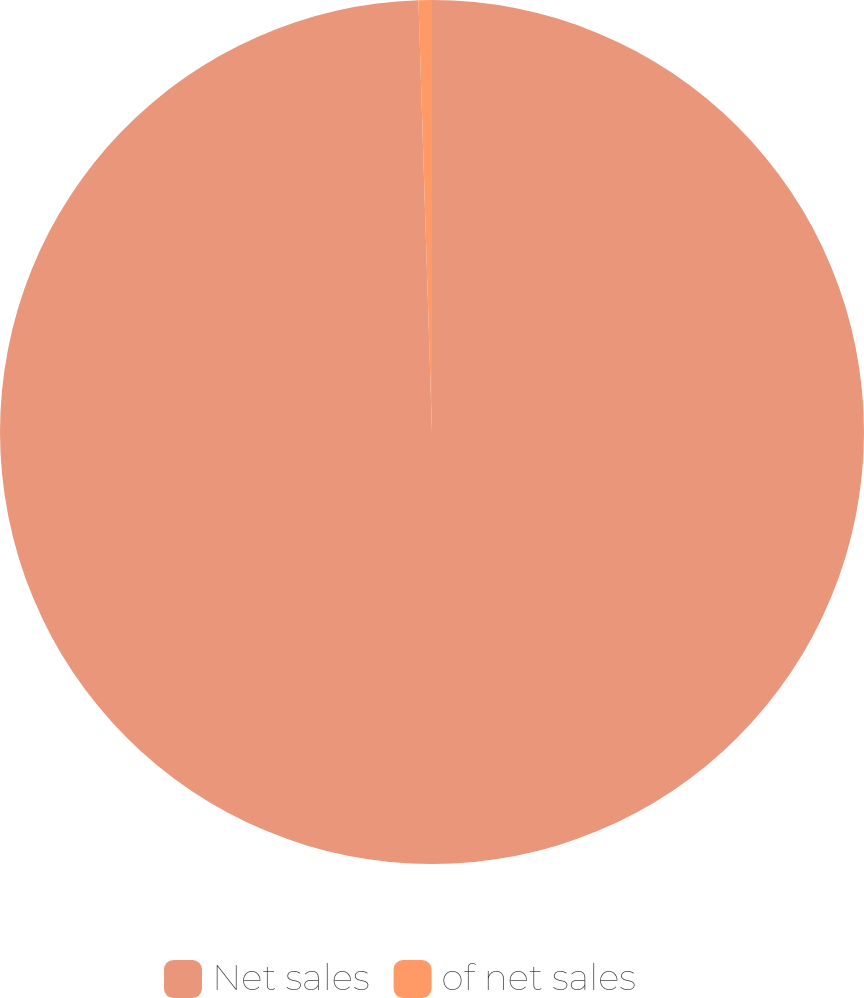<chart> <loc_0><loc_0><loc_500><loc_500><pie_chart><fcel>Net sales<fcel>of net sales<nl><fcel>99.5%<fcel>0.5%<nl></chart> 